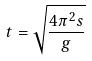Convert formula to latex. <formula><loc_0><loc_0><loc_500><loc_500>t = \sqrt { \frac { 4 \pi ^ { 2 } s } { g } }</formula> 